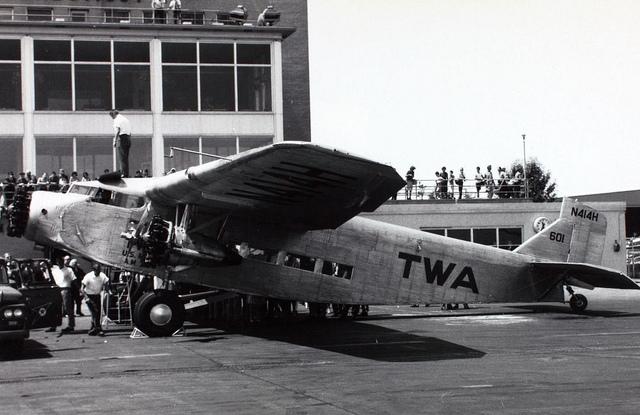What does TWA stand for?
Write a very short answer. Trans world airlines. What is the plane sitting next to?
Answer briefly. Building. What number is on the plane's tail?
Give a very brief answer. 601. 